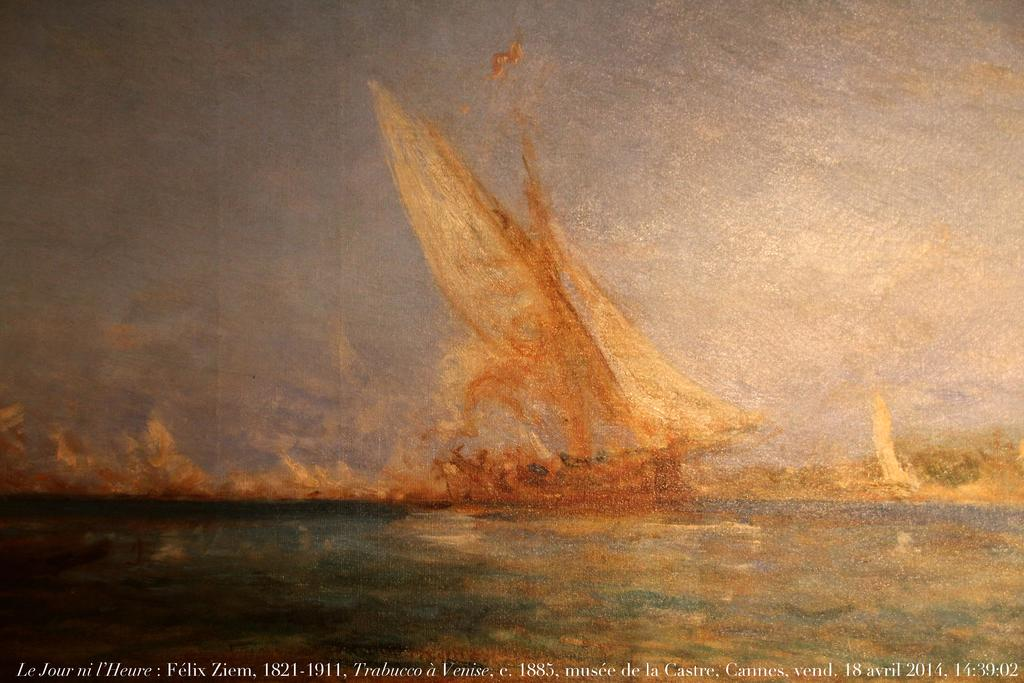<image>
Describe the image concisely. A painting is dated April 18, 2014 and identified with a location of Cannes. 